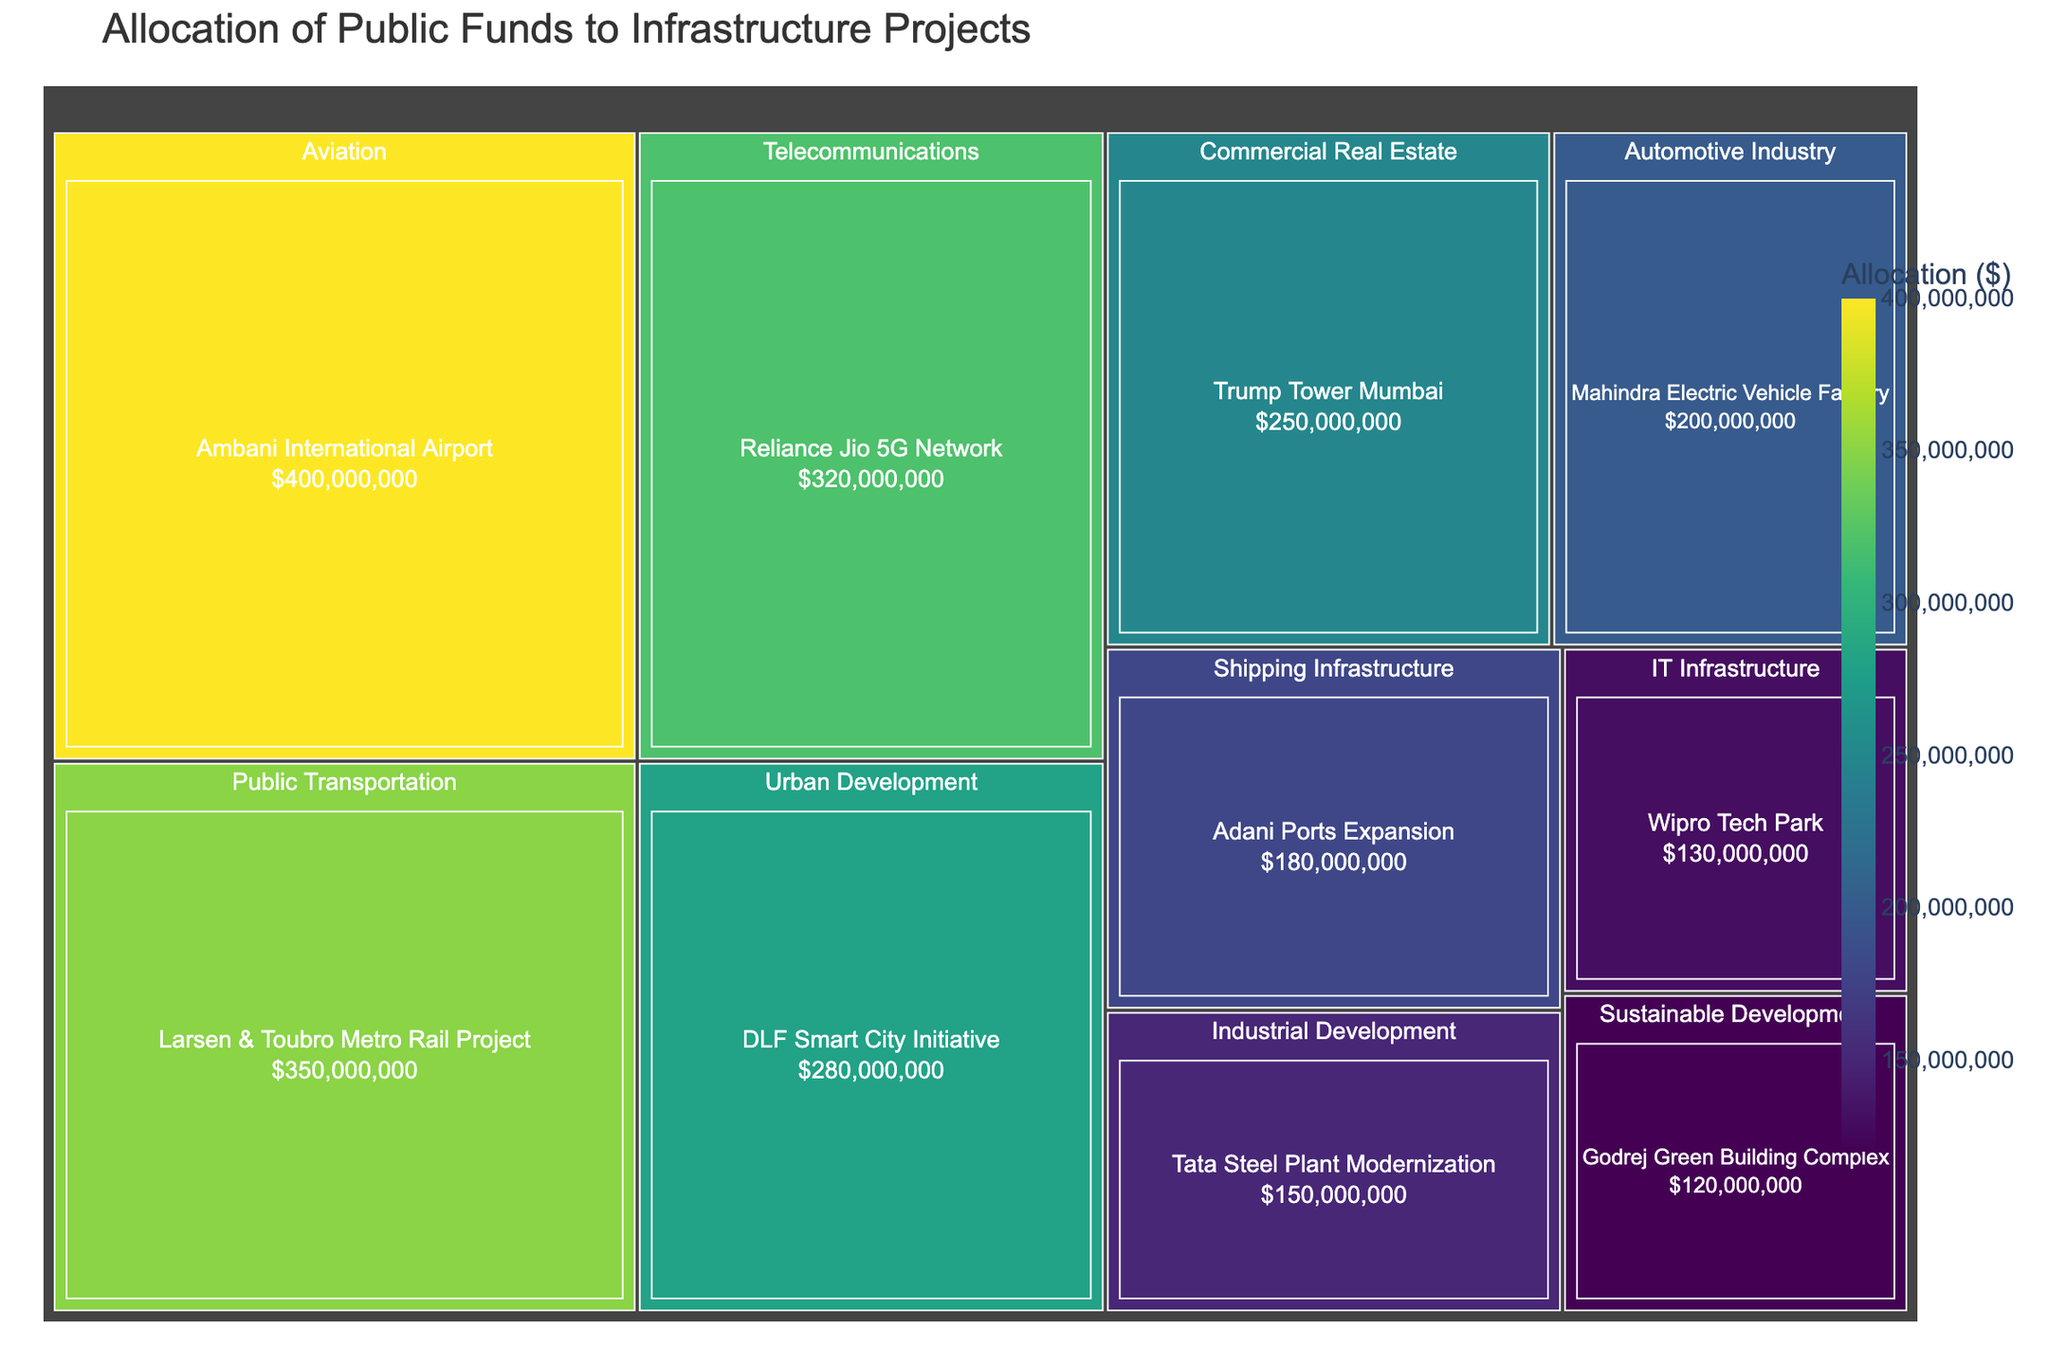What is the title of the figure? The title of the figure is clearly displayed at the top.
Answer: Allocation of Public Funds to Infrastructure Projects Which project received the highest allocation of public funds? To find this, look for the largest rectangle in the treemap, which represents the project with the highest allocation.
Answer: Ambani International Airport What is the allocation for the Adani Ports Expansion project? Locate the rectangle labeled "Adani Ports Expansion" and check the allocation amount displayed within or in the hover details.
Answer: $180,000,000 Which category received the most total funding overall? Sum the allocated funds in each category and identify the category with the highest total. The largest overall section will represent this category.
Answer: Telecommunications Which two projects fall under the 'Sustainable Development' category, and what are their allocations? Look for the 'Sustainable Development' section and note the projects listed under it with their respective allocations.
Answer: Godrej Green Building Complex: $120,000,000 Which project lies in the 'Automotive Industry' category, and how much funding did it receive? Find the 'Automotive Industry' section in the treemap and note the project listed there along with its allocation.
Answer: Mahindra Electric Vehicle Factory: $200,000,000 